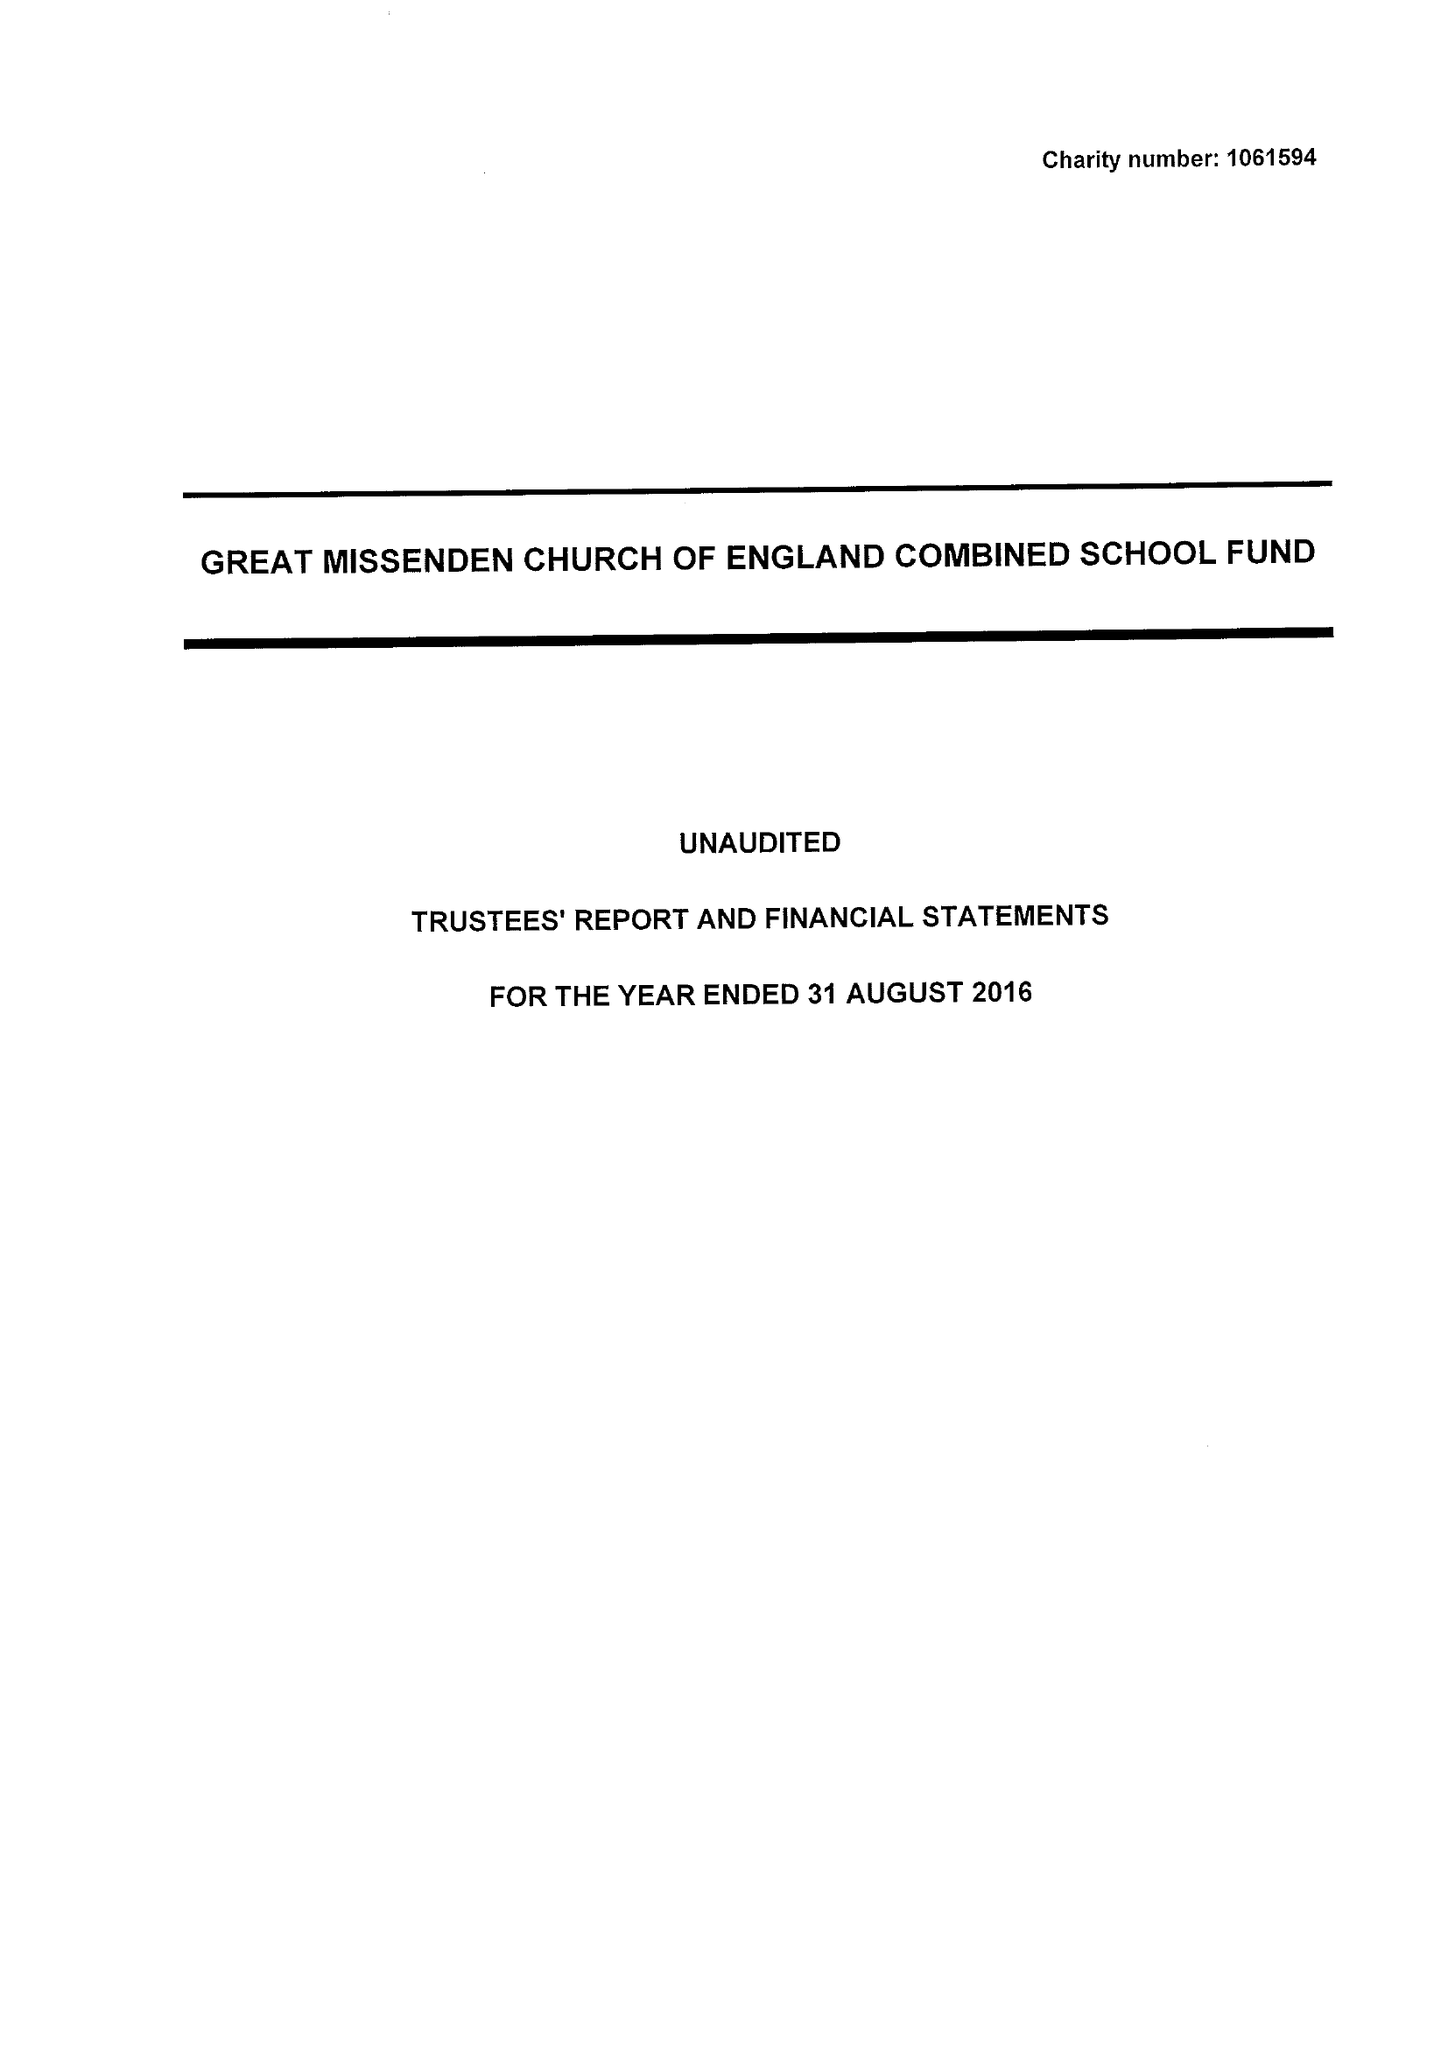What is the value for the spending_annually_in_british_pounds?
Answer the question using a single word or phrase. 264372.00 